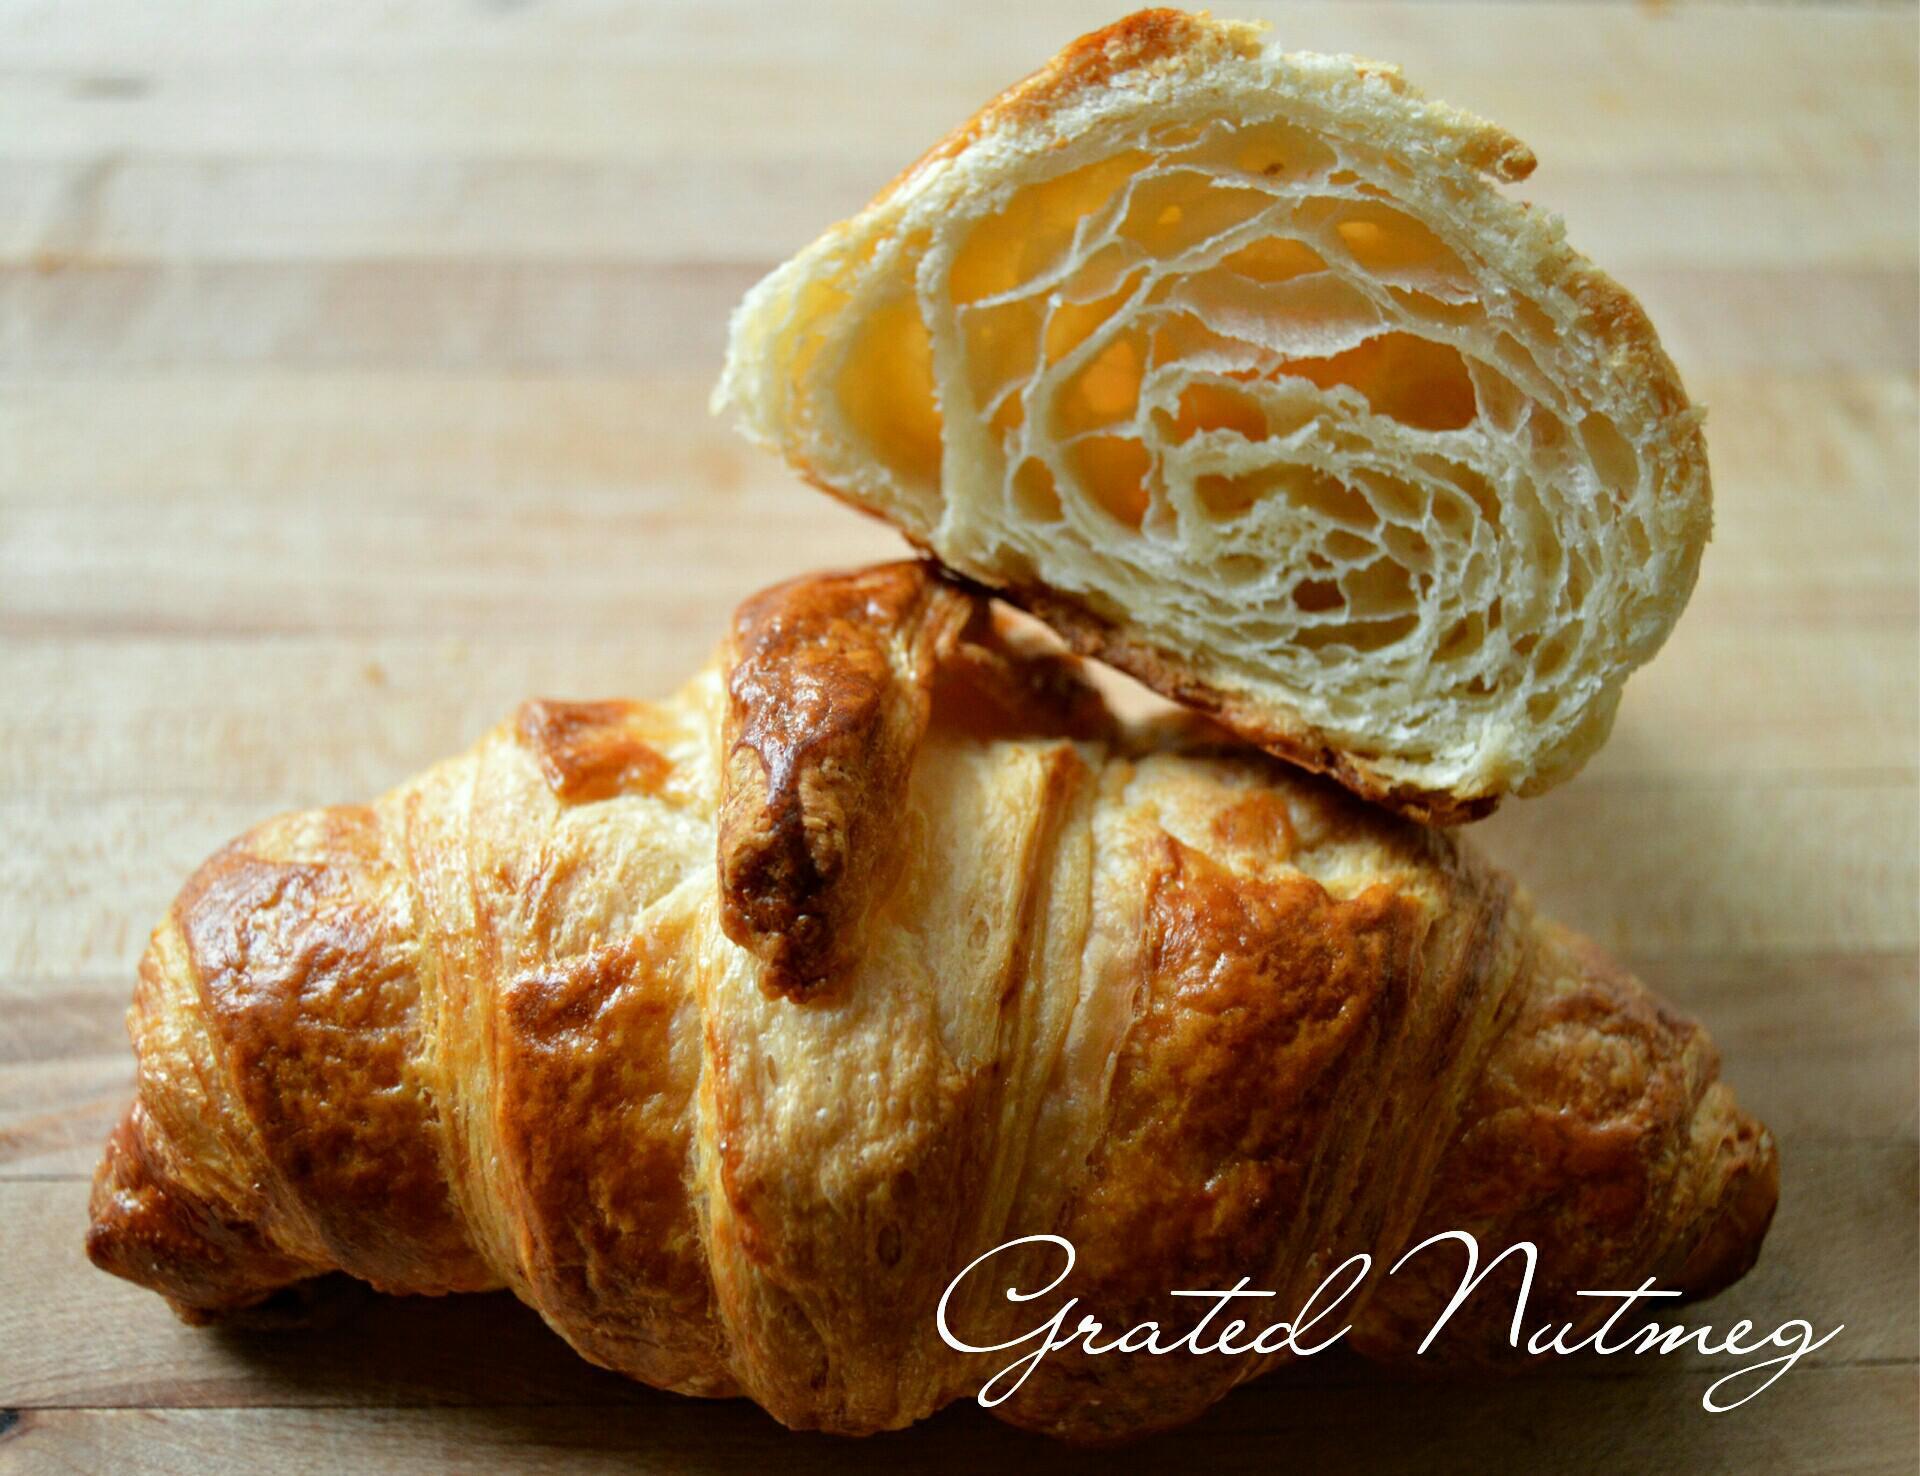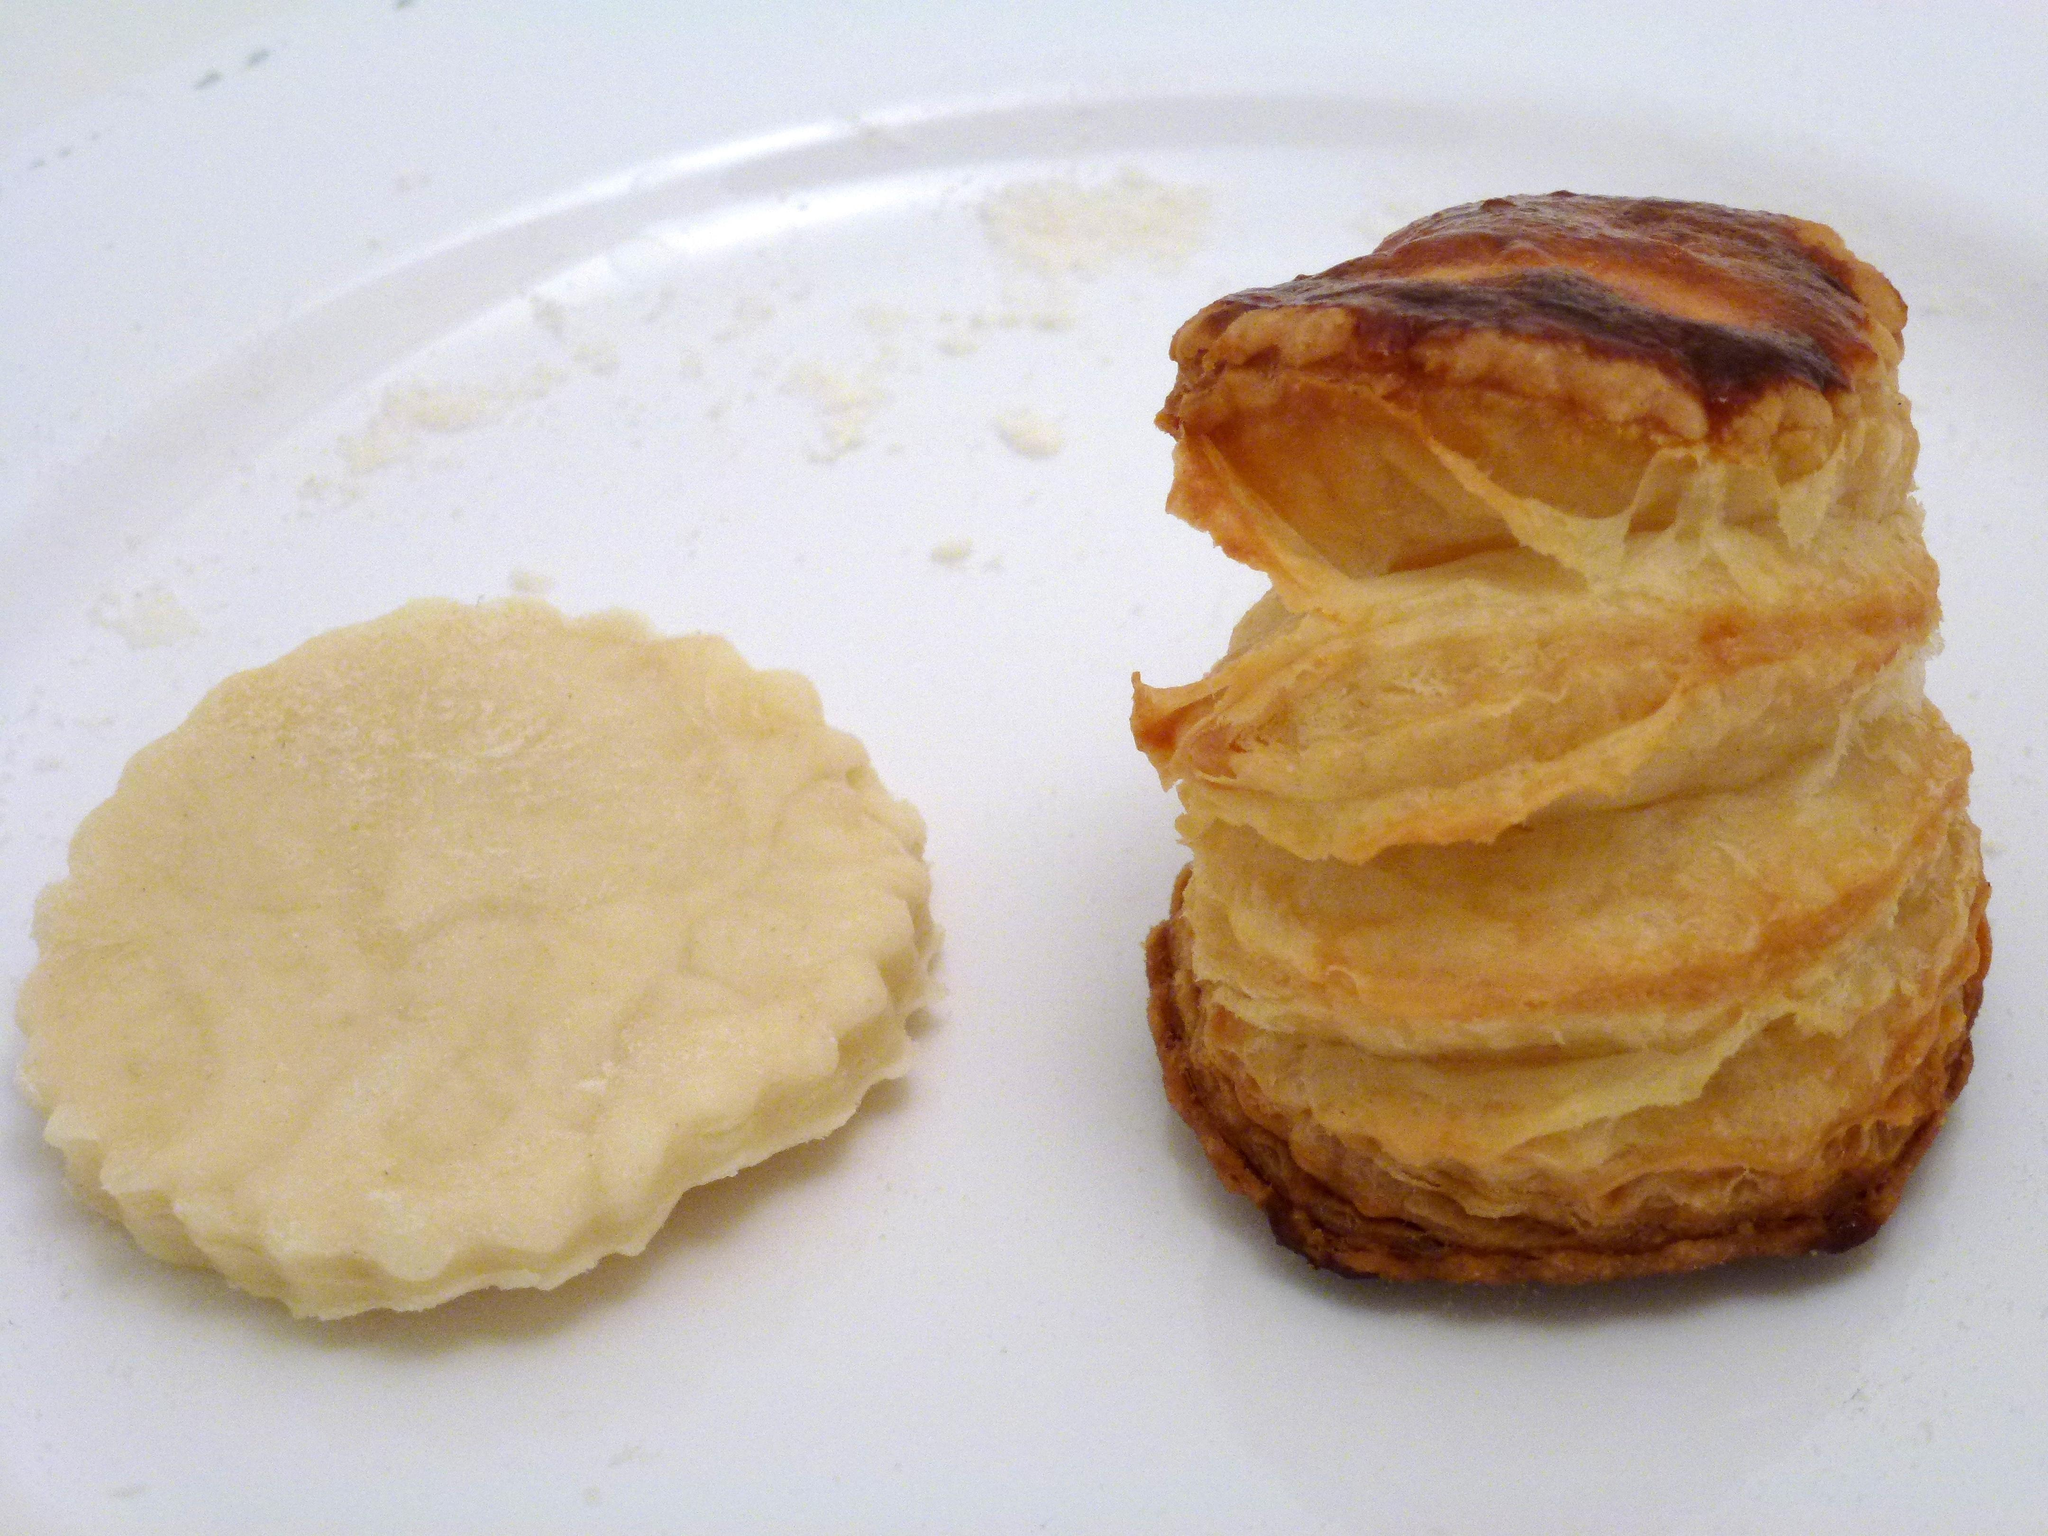The first image is the image on the left, the second image is the image on the right. Assess this claim about the two images: "a piece of bread that is cut in half is showing all the layers and bubbles inside". Correct or not? Answer yes or no. Yes. The first image is the image on the left, the second image is the image on the right. Evaluate the accuracy of this statement regarding the images: "A metal utinsil is near the baking ingredients in the image on the right.". Is it true? Answer yes or no. No. 